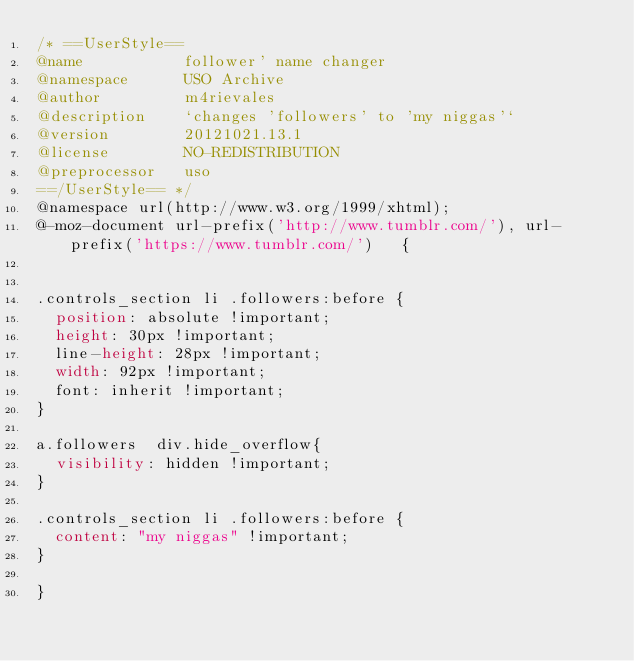Convert code to text. <code><loc_0><loc_0><loc_500><loc_500><_CSS_>/* ==UserStyle==
@name           follower' name changer
@namespace      USO Archive
@author         m4rievales
@description    `changes 'followers' to 'my niggas'`
@version        20121021.13.1
@license        NO-REDISTRIBUTION
@preprocessor   uso
==/UserStyle== */
@namespace url(http://www.w3.org/1999/xhtml);
@-moz-document url-prefix('http://www.tumblr.com/'), url-prefix('https://www.tumblr.com/')   {


.controls_section li .followers:before {
  position: absolute !important;
  height: 30px !important;
  line-height: 28px !important;
  width: 92px !important;
  font: inherit !important;
}

a.followers  div.hide_overflow{
  visibility: hidden !important;
}

.controls_section li .followers:before {
  content: "my niggas" !important;
}

}</code> 